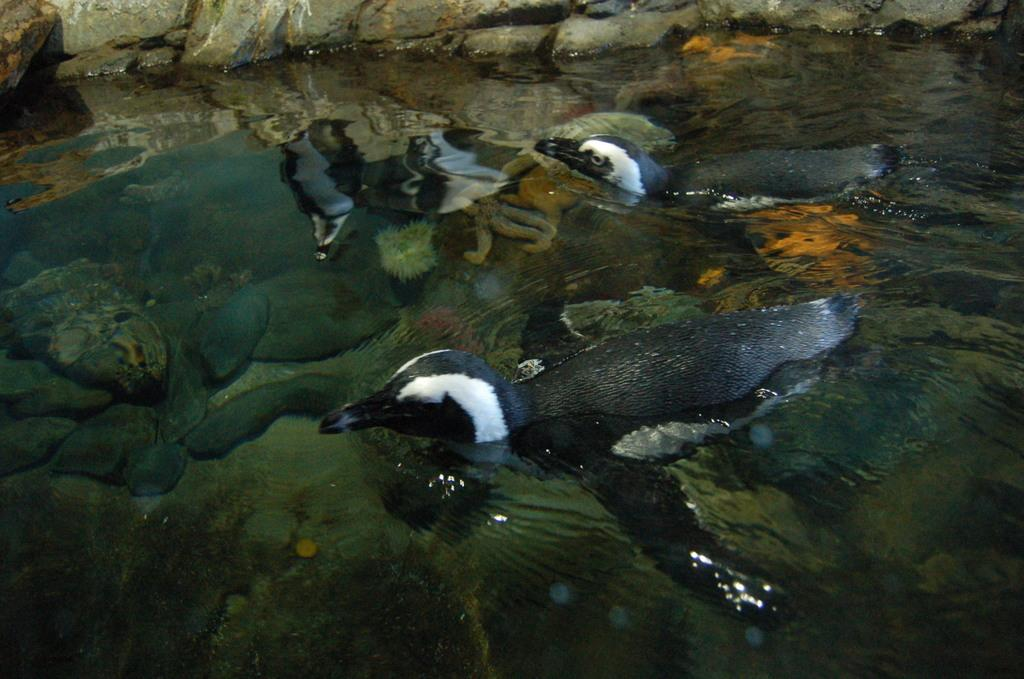What type of animals can be seen in the image? Birds can be seen in the image. What is the primary element in which the birds are situated? The birds are situated in water. What other objects can be seen in the image? There are rocks visible in the image. What type of toy can be seen floating in the water in the image? There is no toy present in the image; it features birds in the water. 